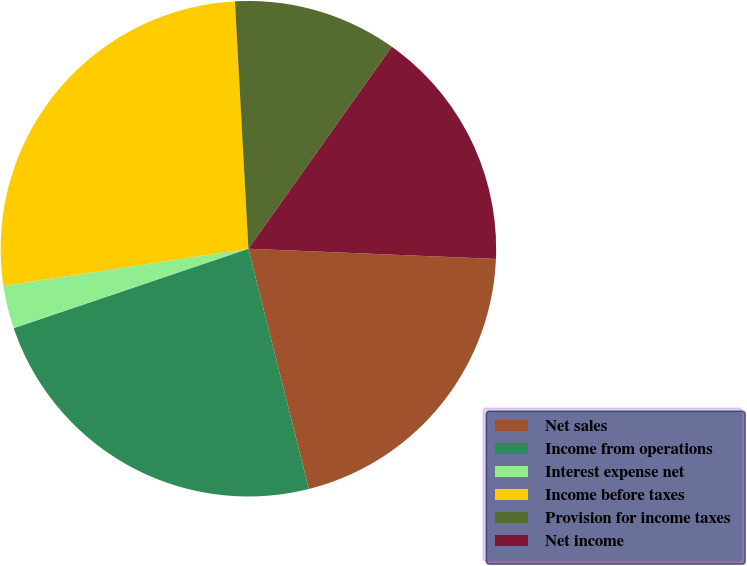<chart> <loc_0><loc_0><loc_500><loc_500><pie_chart><fcel>Net sales<fcel>Income from operations<fcel>Interest expense net<fcel>Income before taxes<fcel>Provision for income taxes<fcel>Net income<nl><fcel>20.42%<fcel>23.73%<fcel>2.8%<fcel>26.53%<fcel>10.69%<fcel>15.83%<nl></chart> 